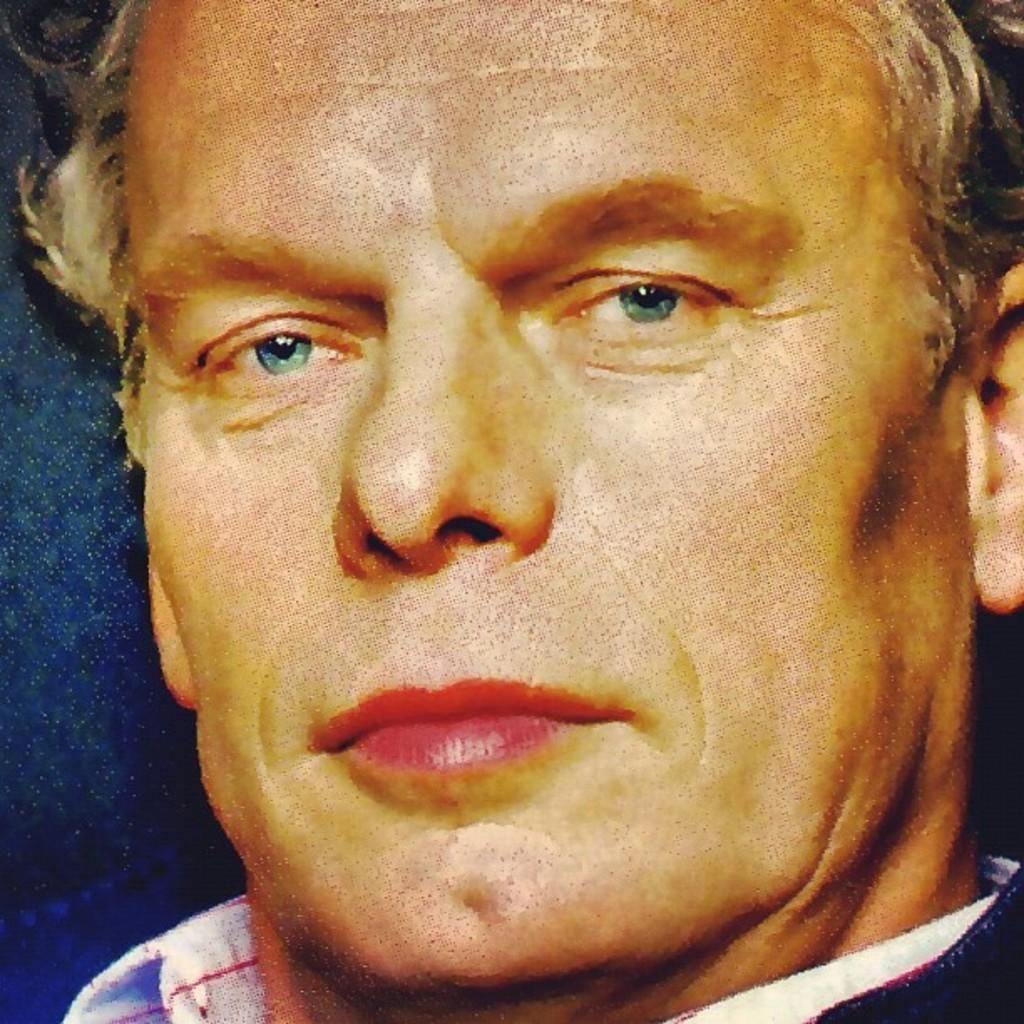Could you give a brief overview of what you see in this image? In the picture I can see a man's face. 